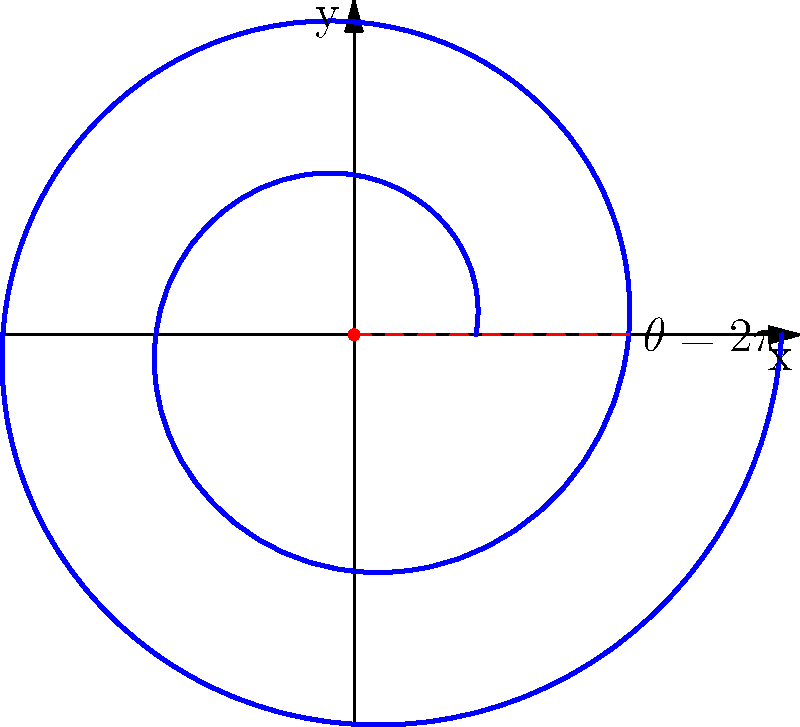A Celtic spiral design is modeled by the polar equation $r = 1 + 0.2\theta$, where $r$ is the distance from the center and $\theta$ is the angle in radians. Calculate the rate of change of the curvature with respect to $\theta$ at $\theta = 2\pi$. To solve this problem, we'll follow these steps:

1) The curvature $\kappa$ of a curve in polar coordinates is given by:

   $$\kappa = \frac{|r^2 + 2(r')^2 - rr''|}{(r^2 + (r')^2)^{3/2}}$$

2) For our spiral, $r = 1 + 0.2\theta$. Let's calculate the derivatives:
   
   $r' = 0.2$
   $r'' = 0$

3) Substituting these into the curvature formula:

   $$\kappa = \frac{|(1 + 0.2\theta)^2 + 2(0.2)^2 - (1 + 0.2\theta)(0)|}{((1 + 0.2\theta)^2 + (0.2)^2)^{3/2}}$$

4) Simplify:

   $$\kappa = \frac{(1 + 0.2\theta)^2 + 0.08}{((1 + 0.2\theta)^2 + 0.04)^{3/2}}$$

5) To find the rate of change of curvature, we need to differentiate $\kappa$ with respect to $\theta$:

   $$\frac{d\kappa}{d\theta} = \frac{0.4(1 + 0.2\theta)((1 + 0.2\theta)^2 + 0.04) - 1.5(0.4)(1 + 0.2\theta)((1 + 0.2\theta)^2 + 0.08)}{((1 + 0.2\theta)^2 + 0.04)^{5/2}}$$

6) At $\theta = 2\pi$, substitute this value:

   $$\frac{d\kappa}{d\theta}\bigg|_{\theta = 2\pi} = \frac{0.4(1 + 0.4\pi)((1 + 0.4\pi)^2 + 0.04) - 1.5(0.4)(1 + 0.4\pi)((1 + 0.4\pi)^2 + 0.08)}{((1 + 0.4\pi)^2 + 0.04)^{5/2}}$$

7) Evaluate this expression numerically to get the final answer.
Answer: $-0.0246$ (rounded to 4 decimal places) 